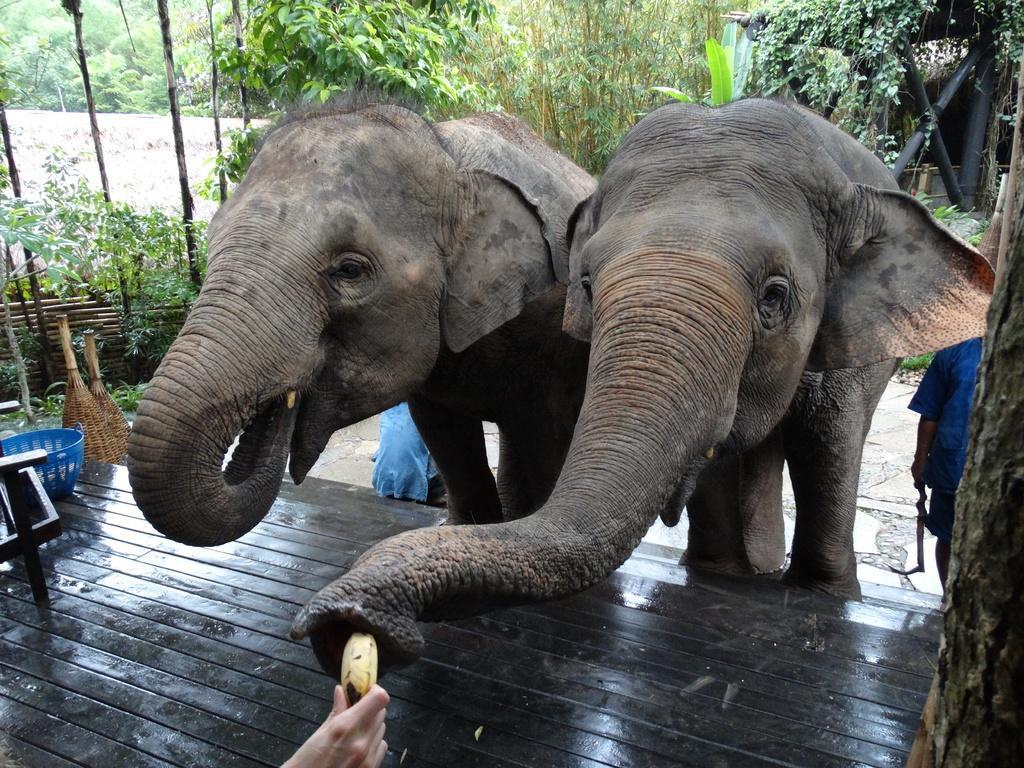Describe this image in one or two sentences. There are elephants. In the background there are trees. In the front there is a wooden floor. And we can see a person holding a banana. On the floor there is a basket. Also there is a person standing near to the elephant and another person is sitting. 